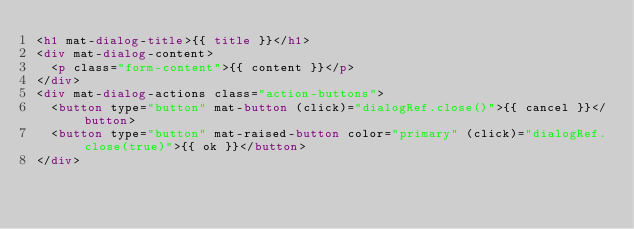Convert code to text. <code><loc_0><loc_0><loc_500><loc_500><_HTML_><h1 mat-dialog-title>{{ title }}</h1>
<div mat-dialog-content>
	<p class="form-content">{{ content }}</p>
</div>
<div mat-dialog-actions class="action-buttons">
	<button type="button" mat-button (click)="dialogRef.close()">{{ cancel }}</button>
	<button type="button" mat-raised-button color="primary" (click)="dialogRef.close(true)">{{ ok }}</button>
</div></code> 